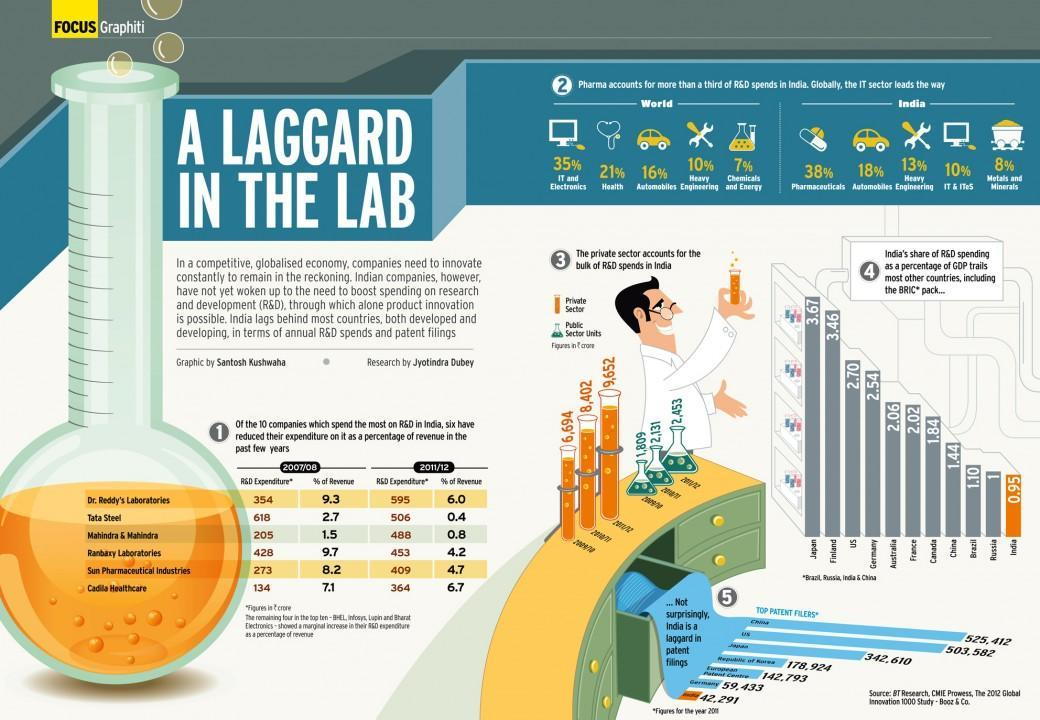What is the percentage of Automobiles in the world?
Answer the question with a short phrase. 16% What is the percentage of revenue for tata steel in 2007 and 2011, taken together? 3.1 What is the percentage of Automobiles in India? 18% What is the percentage of Health and Automobiles together in the world? 37% 